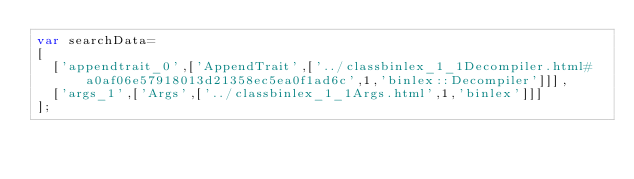Convert code to text. <code><loc_0><loc_0><loc_500><loc_500><_JavaScript_>var searchData=
[
  ['appendtrait_0',['AppendTrait',['../classbinlex_1_1Decompiler.html#a0af06e57918013d21358ec5ea0f1ad6c',1,'binlex::Decompiler']]],
  ['args_1',['Args',['../classbinlex_1_1Args.html',1,'binlex']]]
];
</code> 